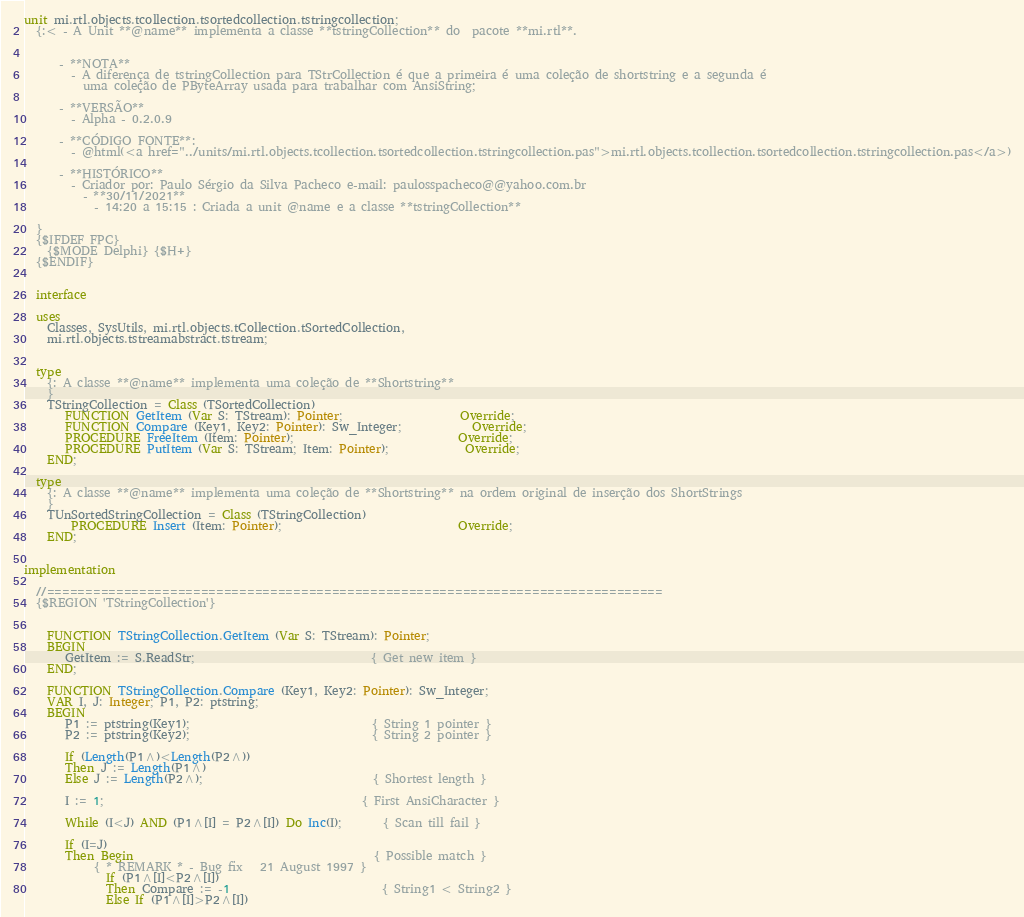Convert code to text. <code><loc_0><loc_0><loc_500><loc_500><_Pascal_>unit mi.rtl.objects.tcollection.tsortedcollection.tstringcollection;
  {:< - A Unit **@name** implementa a classe **tstringCollection** do  pacote **mi.rtl**.


      - **NOTA**
        - A diferença de tstringCollection para TStrCollection é que a primeira é uma coleção de shortstring e a segunda é
          uma coleção de PByteArray usada para trabalhar com AnsiString;

      - **VERSÃO**
        - Alpha - 0.2.0.9

      - **CÓDIGO FONTE**:
        - @html(<a href="../units/mi.rtl.objects.tcollection.tsortedcollection.tstringcollection.pas">mi.rtl.objects.tcollection.tsortedcollection.tstringcollection.pas</a>)

      - **HISTÓRICO**
        - Criador por: Paulo Sérgio da Silva Pacheco e-mail: paulosspacheco@@yahoo.com.br
          - **30/11/2021**
            - 14:20 a 15:15 : Criada a unit @name e a classe **tstringCollection**

  }
  {$IFDEF FPC}
    {$MODE Delphi} {$H+}
  {$ENDIF}


  interface

  uses
    Classes, SysUtils, mi.rtl.objects.tCollection.tSortedCollection,
    mi.rtl.objects.tstreamabstract.tstream;


  type
    {: A classe **@name** implementa uma coleção de **Shortstring**
    }
    TStringCollection = Class (TSortedCollection)
       FUNCTION GetItem (Var S: TStream): Pointer;                    Override;
       FUNCTION Compare (Key1, Key2: Pointer): Sw_Integer;            Override;
       PROCEDURE FreeItem (Item: Pointer);                            Override;
       PROCEDURE PutItem (Var S: TStream; Item: Pointer);             Override;
    END;

  type
    {: A classe **@name** implementa uma coleção de **Shortstring** na ordem original de inserção dos ShortStrings
    }
    TUnSortedStringCollection = Class (TStringCollection)
        PROCEDURE Insert (Item: Pointer);                              Override;
    END;


implementation

  //================================================================================
  {$REGION 'TStringCollection'}


    FUNCTION TStringCollection.GetItem (Var S: TStream): Pointer;
    BEGIN
       GetItem := S.ReadStr;                              { Get new item }
    END;

    FUNCTION TStringCollection.Compare (Key1, Key2: Pointer): Sw_Integer;
    VAR I, J: Integer; P1, P2: ptstring;
    BEGIN
       P1 := ptstring(Key1);                               { String 1 pointer }
       P2 := ptstring(Key2);                               { String 2 pointer }

       If (Length(P1^)<Length(P2^))
       Then J := Length(P1^)
       Else J := Length(P2^);                             { Shortest length }

       I := 1;                                            { First AnsiCharacter }

       While (I<J) AND (P1^[I] = P2^[I]) Do Inc(I);       { Scan till fail }

       If (I=J)
       Then Begin                                         { Possible match }
            { * REMARK * - Bug fix   21 August 1997 }
              If (P1^[I]<P2^[I])
              Then Compare := -1                          { String1 < String2 }
              Else If (P1^[I]>P2^[I])</code> 